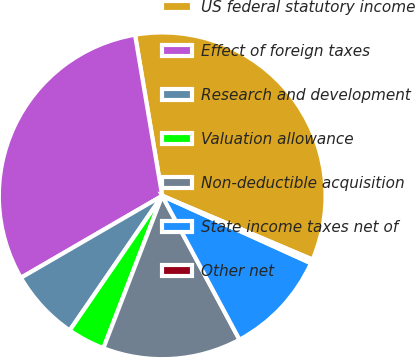Convert chart to OTSL. <chart><loc_0><loc_0><loc_500><loc_500><pie_chart><fcel>US federal statutory income<fcel>Effect of foreign taxes<fcel>Research and development<fcel>Valuation allowance<fcel>Non-deductible acquisition<fcel>State income taxes net of<fcel>Other net<nl><fcel>34.05%<fcel>30.71%<fcel>7.05%<fcel>3.72%<fcel>13.71%<fcel>10.38%<fcel>0.39%<nl></chart> 